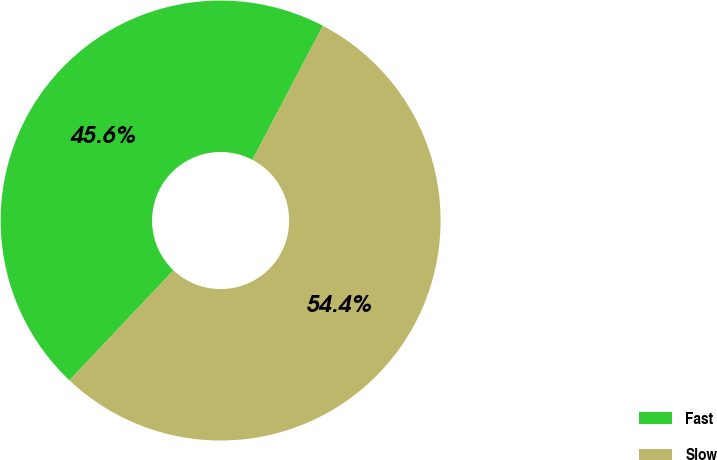<chart> <loc_0><loc_0><loc_500><loc_500><pie_chart><fcel>Fast<fcel>Slow<nl><fcel>45.64%<fcel>54.36%<nl></chart> 